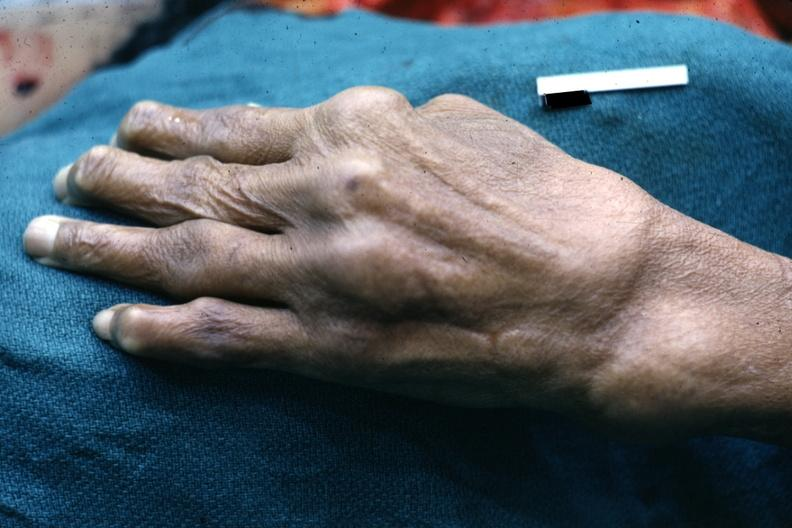what are present?
Answer the question using a single word or phrase. Extremities 